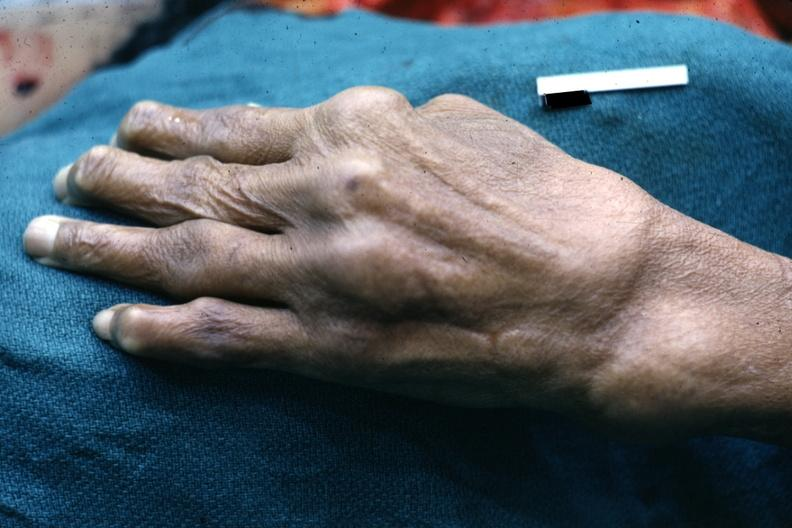what are present?
Answer the question using a single word or phrase. Extremities 